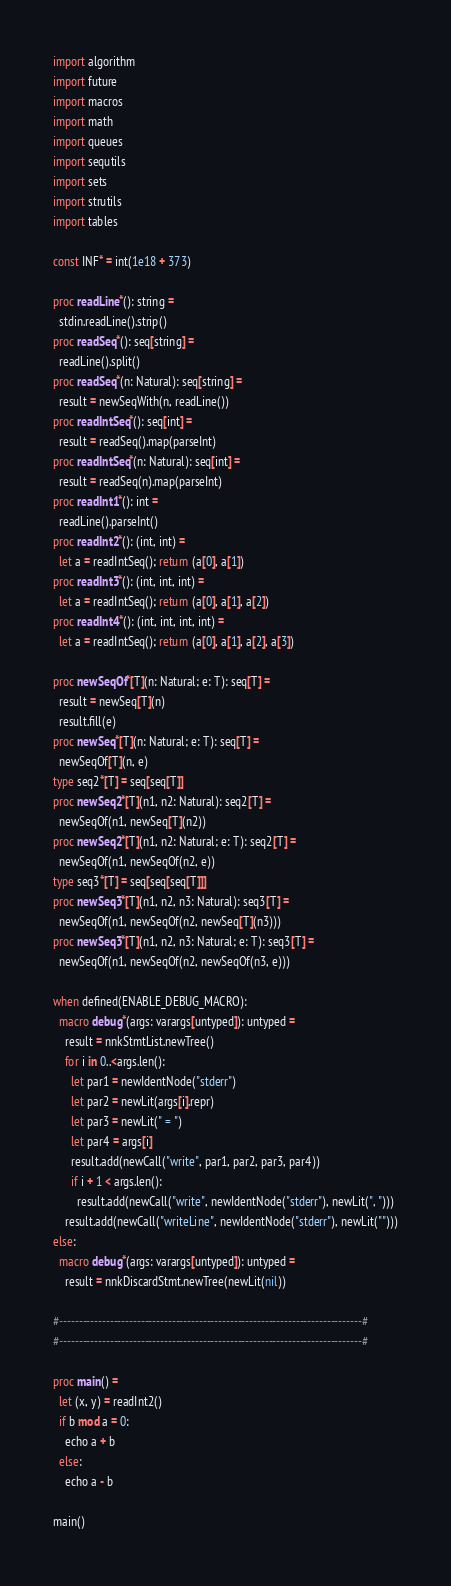<code> <loc_0><loc_0><loc_500><loc_500><_Nim_>import algorithm
import future
import macros
import math
import queues
import sequtils
import sets
import strutils
import tables

const INF* = int(1e18 + 373)

proc readLine*(): string =
  stdin.readLine().strip()
proc readSeq*(): seq[string] =
  readLine().split()
proc readSeq*(n: Natural): seq[string] =
  result = newSeqWith(n, readLine())
proc readIntSeq*(): seq[int] =
  result = readSeq().map(parseInt)
proc readIntSeq*(n: Natural): seq[int] =
  result = readSeq(n).map(parseInt)
proc readInt1*(): int =
  readLine().parseInt()
proc readInt2*(): (int, int) =
  let a = readIntSeq(); return (a[0], a[1])
proc readInt3*(): (int, int, int) =
  let a = readIntSeq(); return (a[0], a[1], a[2])
proc readInt4*(): (int, int, int, int) =
  let a = readIntSeq(); return (a[0], a[1], a[2], a[3])

proc newSeqOf*[T](n: Natural; e: T): seq[T] =
  result = newSeq[T](n)
  result.fill(e)
proc newSeq*[T](n: Natural; e: T): seq[T] =
  newSeqOf[T](n, e)
type seq2*[T] = seq[seq[T]]
proc newSeq2*[T](n1, n2: Natural): seq2[T] =
  newSeqOf(n1, newSeq[T](n2))
proc newSeq2*[T](n1, n2: Natural; e: T): seq2[T] =
  newSeqOf(n1, newSeqOf(n2, e))
type seq3*[T] = seq[seq[seq[T]]]
proc newSeq3*[T](n1, n2, n3: Natural): seq3[T] =
  newSeqOf(n1, newSeqOf(n2, newSeq[T](n3)))
proc newSeq3*[T](n1, n2, n3: Natural; e: T): seq3[T] =
  newSeqOf(n1, newSeqOf(n2, newSeqOf(n3, e)))

when defined(ENABLE_DEBUG_MACRO):
  macro debug*(args: varargs[untyped]): untyped =
    result = nnkStmtList.newTree()
    for i in 0..<args.len():
      let par1 = newIdentNode("stderr")
      let par2 = newLit(args[i].repr)
      let par3 = newLit(" = ")
      let par4 = args[i]
      result.add(newCall("write", par1, par2, par3, par4))
      if i + 1 < args.len():
        result.add(newCall("write", newIdentNode("stderr"), newLit(", ")))
    result.add(newCall("writeLine", newIdentNode("stderr"), newLit("")))
else:
  macro debug*(args: varargs[untyped]): untyped =
    result = nnkDiscardStmt.newTree(newLit(nil))

#------------------------------------------------------------------------------#
#------------------------------------------------------------------------------#

proc main() =
  let (x, y) = readInt2()
  if b mod a = 0:
    echo a + b
  else:
    echo a - b

main()
</code> 